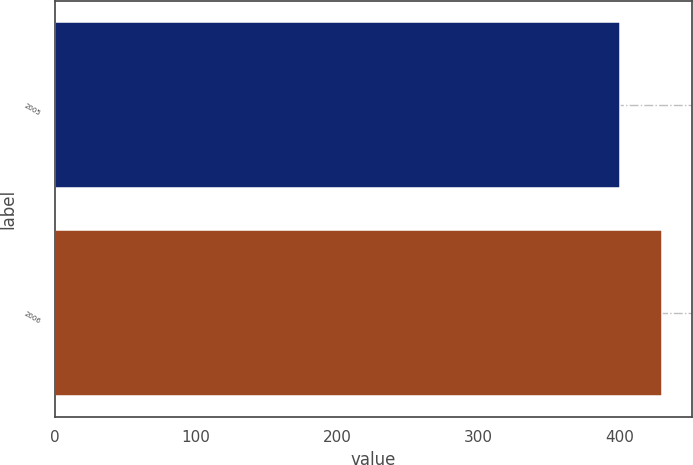Convert chart to OTSL. <chart><loc_0><loc_0><loc_500><loc_500><bar_chart><fcel>2005<fcel>2006<nl><fcel>400<fcel>430<nl></chart> 